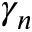<formula> <loc_0><loc_0><loc_500><loc_500>\gamma _ { n }</formula> 